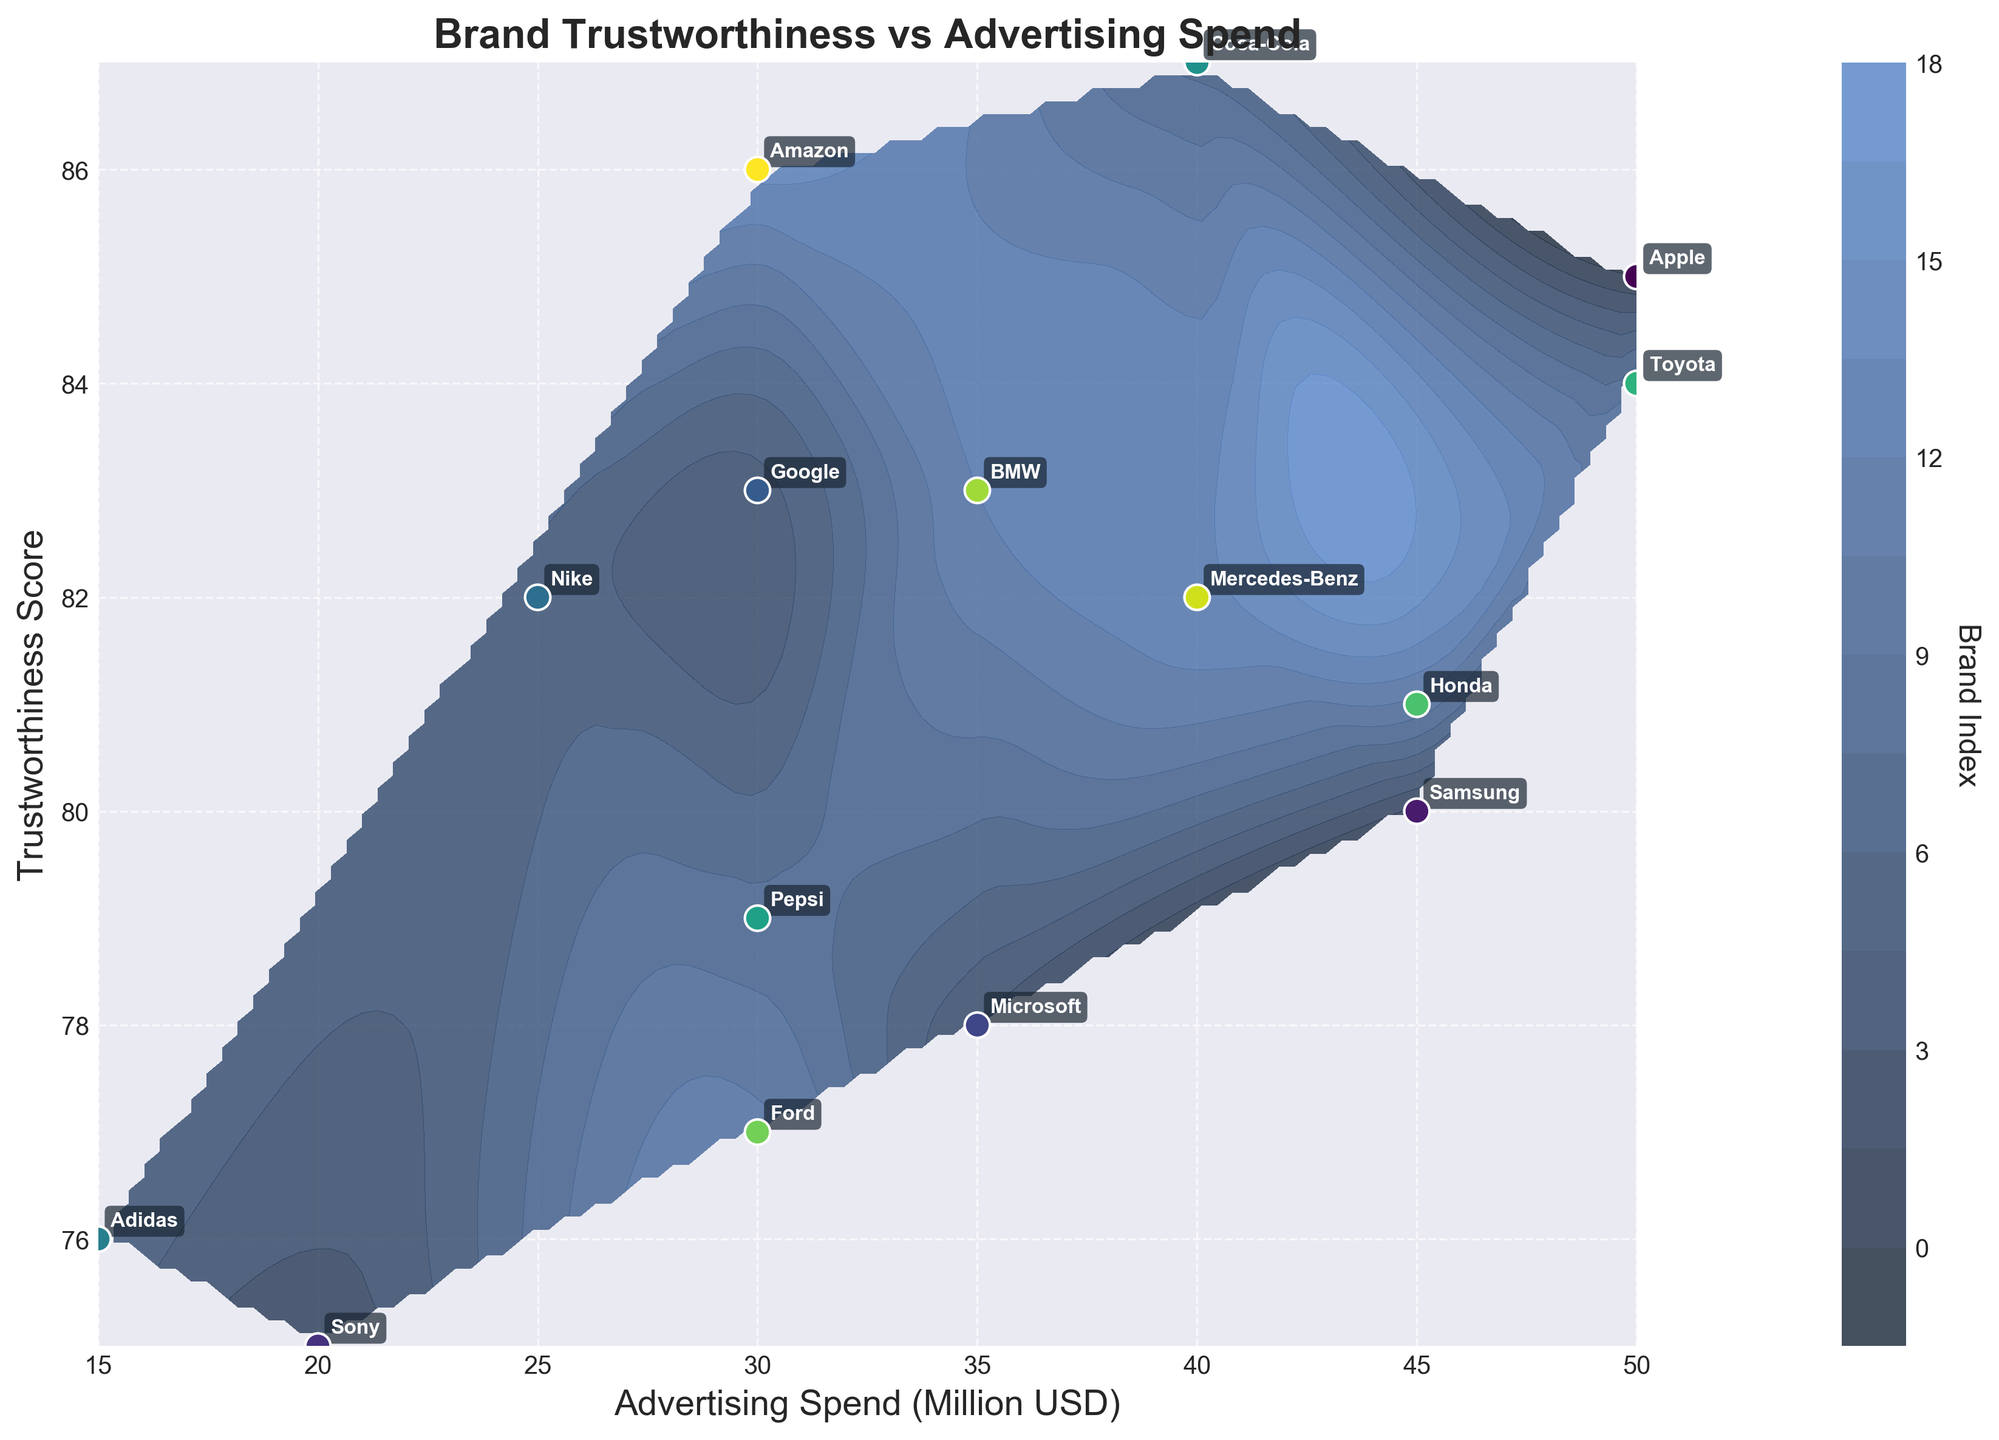How many brands are shown in the plot? The plot includes data points for each brand, identifiable by their label annotations. By counting the distinct brand labels, one can determine the total number of brands.
Answer: 15 What is the range of advertising spend shown on the x-axis? The x-axis represents the advertising spend in millions. By looking at the lowest and highest values on the x-axis, one can determine the range. The minimum value is 15 million USD, and the maximum value is 50 million USD.
Answer: 15 to 50 million USD Which brand has the highest trustworthiness score and how much is it? By observing the y-axis values and identifying the highest plotted point, we can see it corresponds to the brand "Coca-Cola" with a score of 87.
Answer: Coca-Cola, 87 What are the trustworthiness scores for brands that spend 30 million USD on advertising? By finding the points along the vertical line at 30 million USD on the x-axis, we see the trustworthiness scores written for Google, Ford, Amazon, and Pepsi are 83, 77, 86, and 79, respectively.
Answer: Google: 83, Ford: 77, Amazon: 86, Pepsi: 79 Is there a general trend between advertising spend and trustworthiness score? By examining the overall distribution of points and contour lines, there appears to be a slight positive correlation where higher advertising spend tends to align with higher trustworthiness scores, though not perfectly linear.
Answer: Slight positive correlation Which two brands have the closest trustworthiness scores but a significant difference in advertising spend? By analyzing the y-axis for closely positioned points and checking their corresponding x-axis values, Amazon and Google have trustworthiness scores of 86 and 83 respectively, with both spending 30 million USD, resulting in a minimal difference in trustworthiness scores.
Answer: Google and Amazon Between Toyota and Mercedes-Benz, which brand spends more on advertising and how much more? Toyota spends 50 million USD on advertising, whereas Mercedes-Benz spends 40 million USD. The difference is 50 - 40 = 10 million USD.
Answer: Toyota, 10 million USD What's the range of trustworthiness scores provided in the data? The trustworthiness scores in the plot range from the lowest point around 75 (Sony, Adidas) to the highest point at 87 (Coca-Cola).
Answer: 75 to 87 How does the trustworthiness score of Honda compare to that of Samsung, and what's their difference? The trustworthiness score of Honda is 81, while Samsung has a score of 80. The difference is 81 - 80 = 1.
Answer: Honda is higher by 1 Is there any brand with a trustworthiness score below 75? By examining the plot, the lowest score is 75, so no brands have a trustworthiness score below that.
Answer: No 